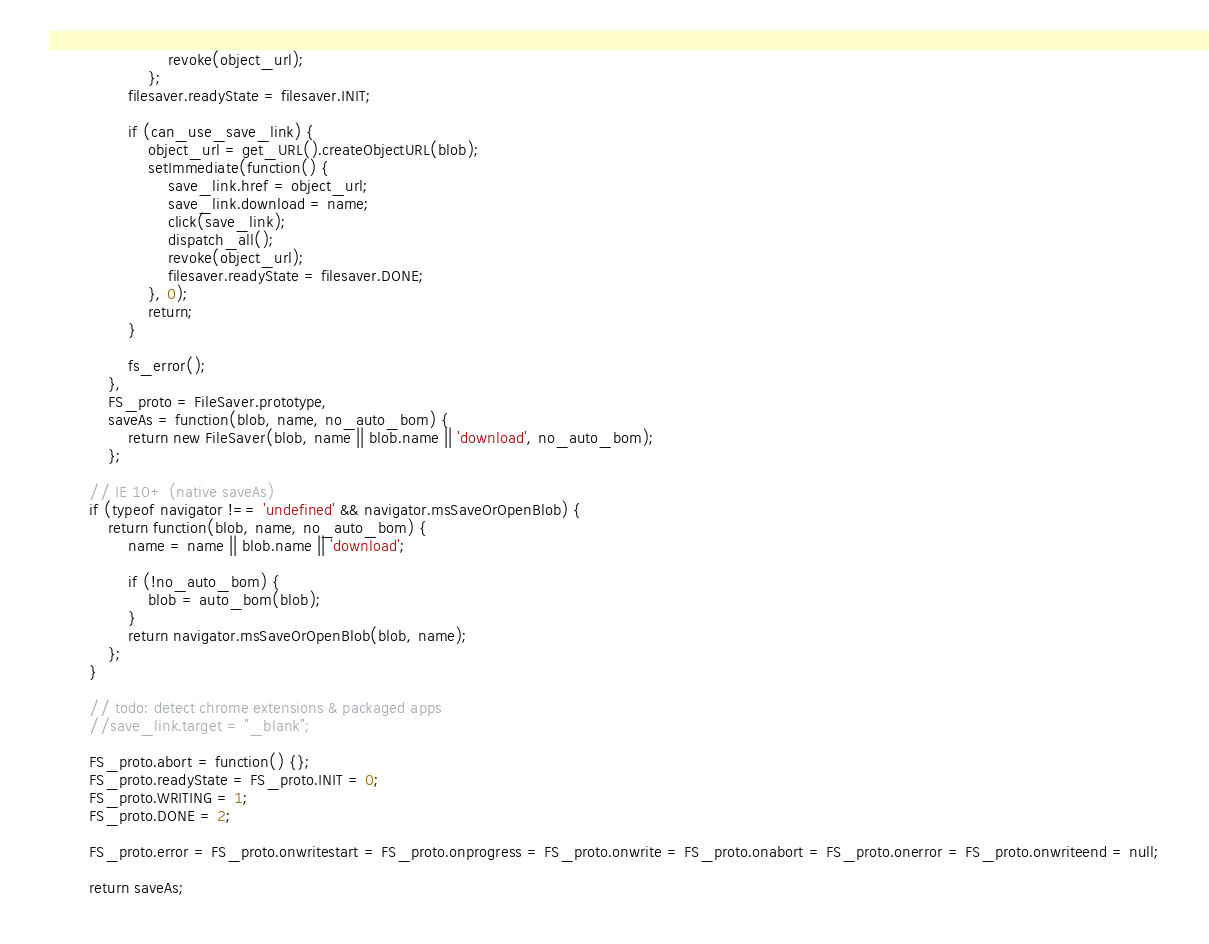Convert code to text. <code><loc_0><loc_0><loc_500><loc_500><_JavaScript_>                        revoke(object_url);
                    };
                filesaver.readyState = filesaver.INIT;

                if (can_use_save_link) {
                    object_url = get_URL().createObjectURL(blob);
                    setImmediate(function() {
                        save_link.href = object_url;
                        save_link.download = name;
                        click(save_link);
                        dispatch_all();
                        revoke(object_url);
                        filesaver.readyState = filesaver.DONE;
                    }, 0);
                    return;
                }

                fs_error();
            },
            FS_proto = FileSaver.prototype,
            saveAs = function(blob, name, no_auto_bom) {
                return new FileSaver(blob, name || blob.name || 'download', no_auto_bom);
            };

        // IE 10+ (native saveAs)
        if (typeof navigator !== 'undefined' && navigator.msSaveOrOpenBlob) {
            return function(blob, name, no_auto_bom) {
                name = name || blob.name || 'download';

                if (!no_auto_bom) {
                    blob = auto_bom(blob);
                }
                return navigator.msSaveOrOpenBlob(blob, name);
            };
        }

        // todo: detect chrome extensions & packaged apps
        //save_link.target = "_blank";

        FS_proto.abort = function() {};
        FS_proto.readyState = FS_proto.INIT = 0;
        FS_proto.WRITING = 1;
        FS_proto.DONE = 2;

        FS_proto.error = FS_proto.onwritestart = FS_proto.onprogress = FS_proto.onwrite = FS_proto.onabort = FS_proto.onerror = FS_proto.onwriteend = null;

        return saveAs;</code> 